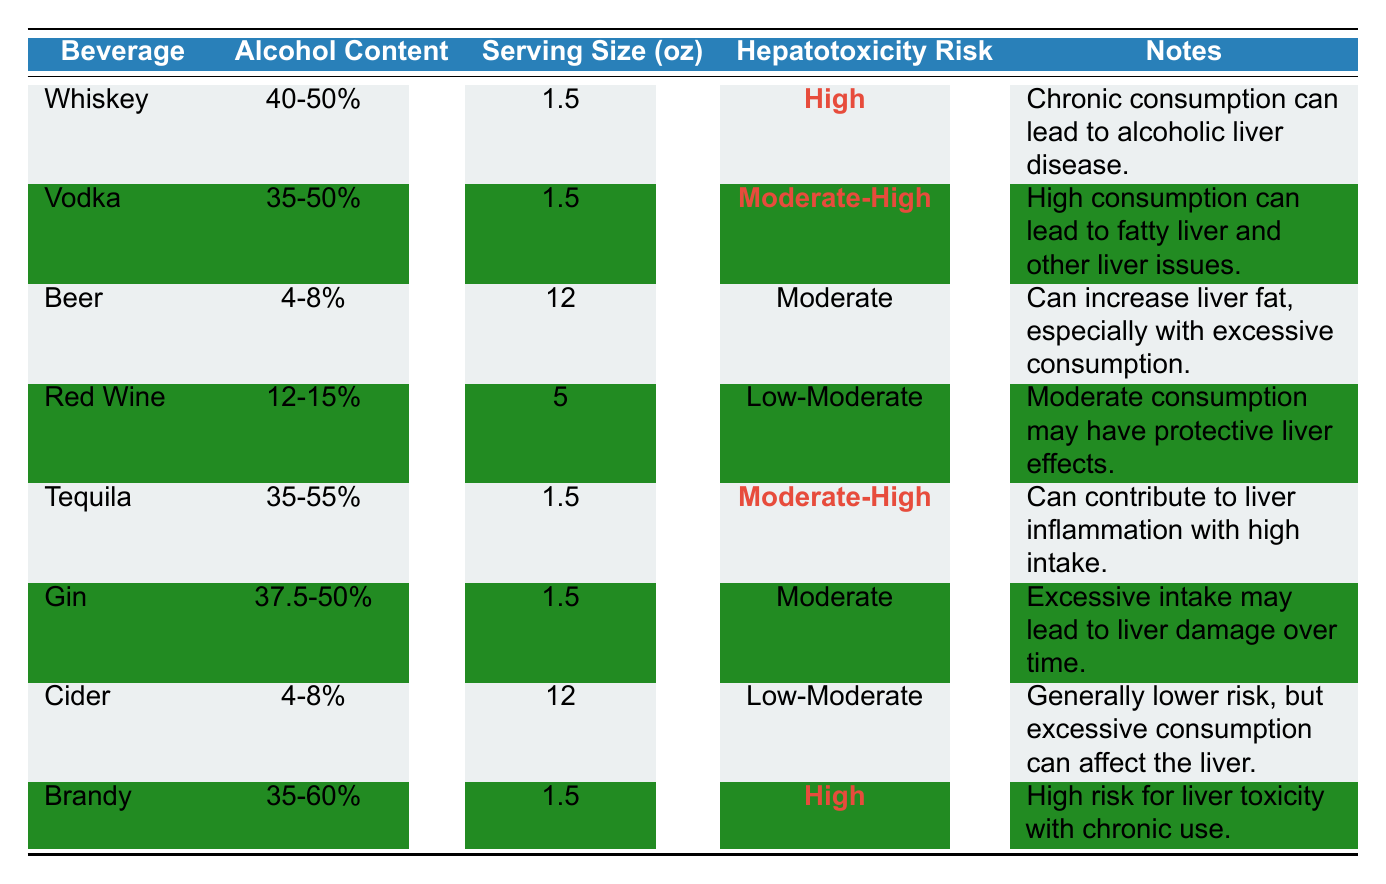What is the hepatotoxicity risk of Whiskey? The table lists the hepatotoxicity risk of Whiskey as "High," which is highlighted for emphasis.
Answer: High Which alcoholic beverage has the lowest hepatotoxicity risk? "Red Wine" and "Cider" are both categorized as Low-Moderate. However, Cider has a lower risk compared to other beverages listed.
Answer: Cider What is the average ethyl alcohol content of Beer and Red Wine? Beer has an ethyl alcohol content of 4-8%, and Red Wine has 12-15%. The average could be calculated by taking the midpoints: Beer (6%) and Red Wine (13.5%), so (6 + 13.5) / 2 = 9.75%.
Answer: 9.75% Does Vodka have a higher average serving size than Whiskey? Both Vodka and Whiskey have the same average serving size of 1.5 oz, therefore, Vodka does not have a higher average serving size compared to Whiskey.
Answer: No Which beverages can lead to liver inflammation with high intake? The table lists both Tequila and Brandy as contributing to liver inflammation at high consumption levels. This information is found in the "Notes" for each beverage.
Answer: Tequila and Brandy What is the difference in average serving size between Beer and Brandy? Beer’s average serving size is 12 oz, while Brandy has an average serving size of 1.5 oz, so the difference is 12 - 1.5 = 10.5 oz.
Answer: 10.5 oz Is the hepatotoxicity risk of Gin higher than that of Red Wine? The table shows that Gin has a "Moderate" hepatotoxicity risk, while Red Wine has a "Low-Moderate" risk, indicating Gin’s risk is higher than that of Red Wine.
Answer: Yes If someone consumes one serving of each type of beverage, which beverage would contribute the highest risk to liver health? According to the hepatotoxicity risk column, both Whiskey and Brandy are categorized as "High." Therefore, these would contribute the highest risk to liver health.
Answer: Whiskey and Brandy How many beverages have a hepatotoxicity risk rated as "Moderate"? The beverages listed with a "Moderate" risk are Beer and Gin; therefore, there are two beverages that fit this criterion.
Answer: 2 What is the average ethyl alcohol content of beverages classified as high hepatotoxicity risk? The ethyl alcohol content for Whiskey (45%) and Brandy (47.5%) could be averaged: (45 + 47.5) / 2 = 46.25%.
Answer: 46.25% 